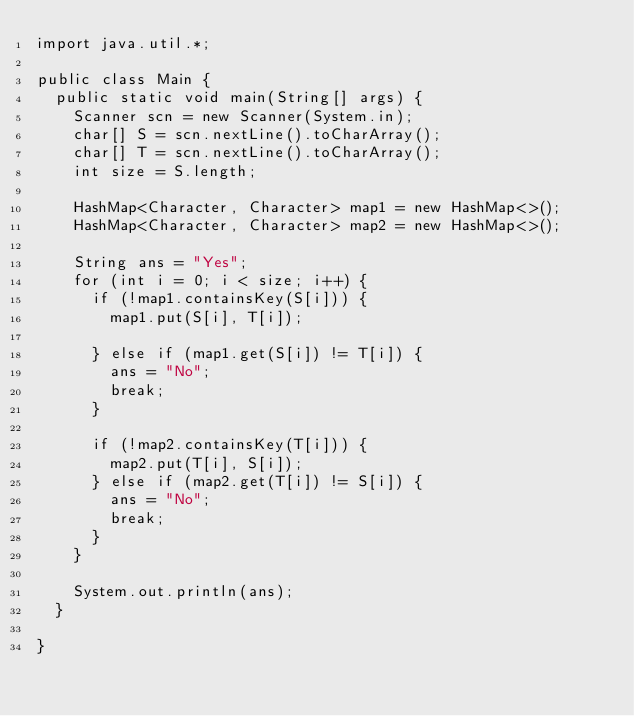<code> <loc_0><loc_0><loc_500><loc_500><_Java_>import java.util.*;

public class Main {
  public static void main(String[] args) {
    Scanner scn = new Scanner(System.in);
    char[] S = scn.nextLine().toCharArray();
    char[] T = scn.nextLine().toCharArray();
    int size = S.length;

    HashMap<Character, Character> map1 = new HashMap<>();
    HashMap<Character, Character> map2 = new HashMap<>();

    String ans = "Yes";
    for (int i = 0; i < size; i++) {
      if (!map1.containsKey(S[i])) {
        map1.put(S[i], T[i]);

      } else if (map1.get(S[i]) != T[i]) {
        ans = "No";
        break;
      }

      if (!map2.containsKey(T[i])) {
        map2.put(T[i], S[i]);
      } else if (map2.get(T[i]) != S[i]) {
        ans = "No";
        break;
      }
    }

    System.out.println(ans);
  }

}
</code> 